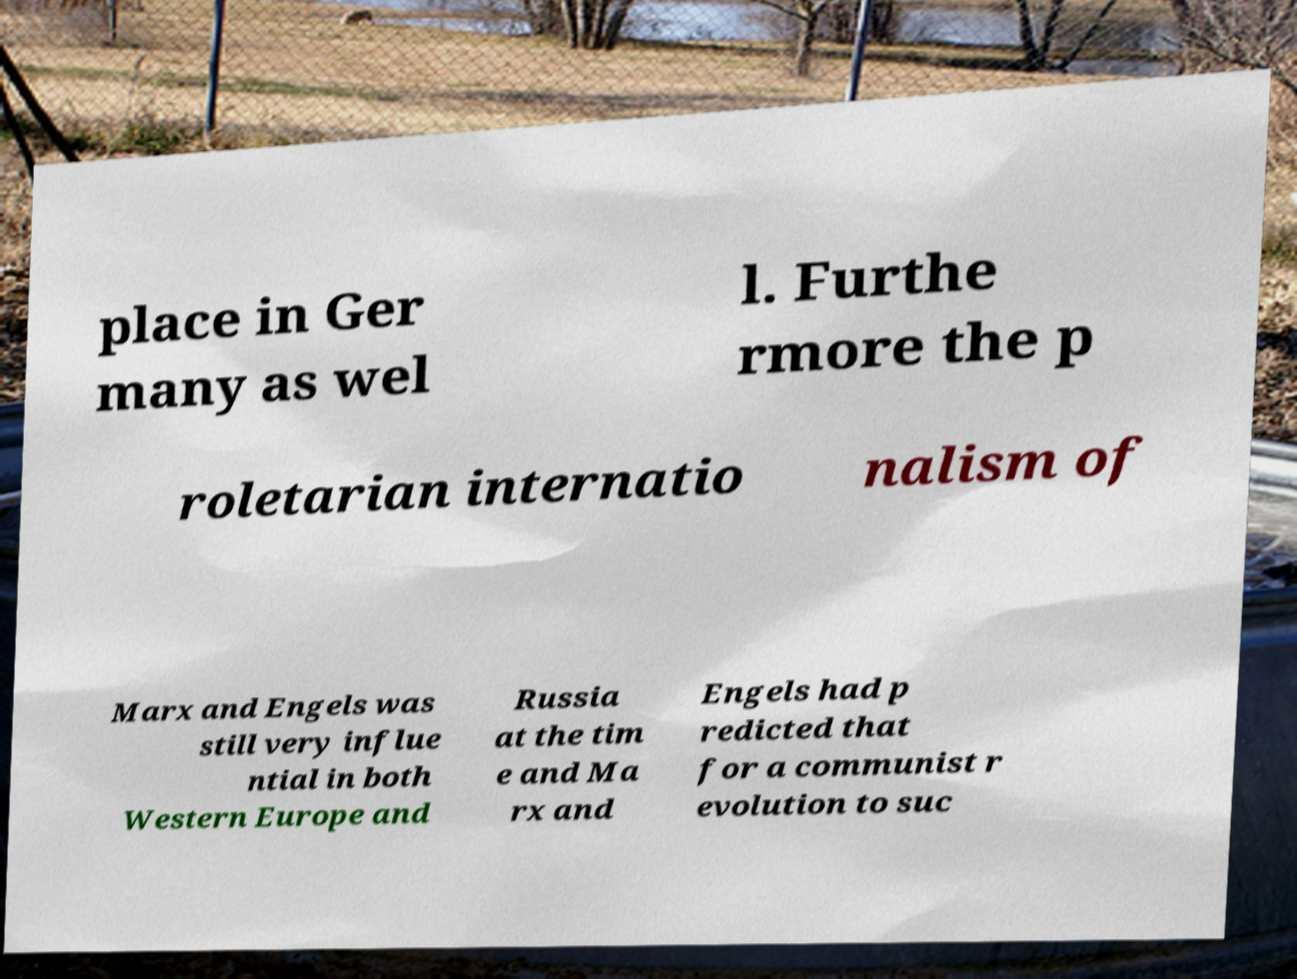Please identify and transcribe the text found in this image. place in Ger many as wel l. Furthe rmore the p roletarian internatio nalism of Marx and Engels was still very influe ntial in both Western Europe and Russia at the tim e and Ma rx and Engels had p redicted that for a communist r evolution to suc 